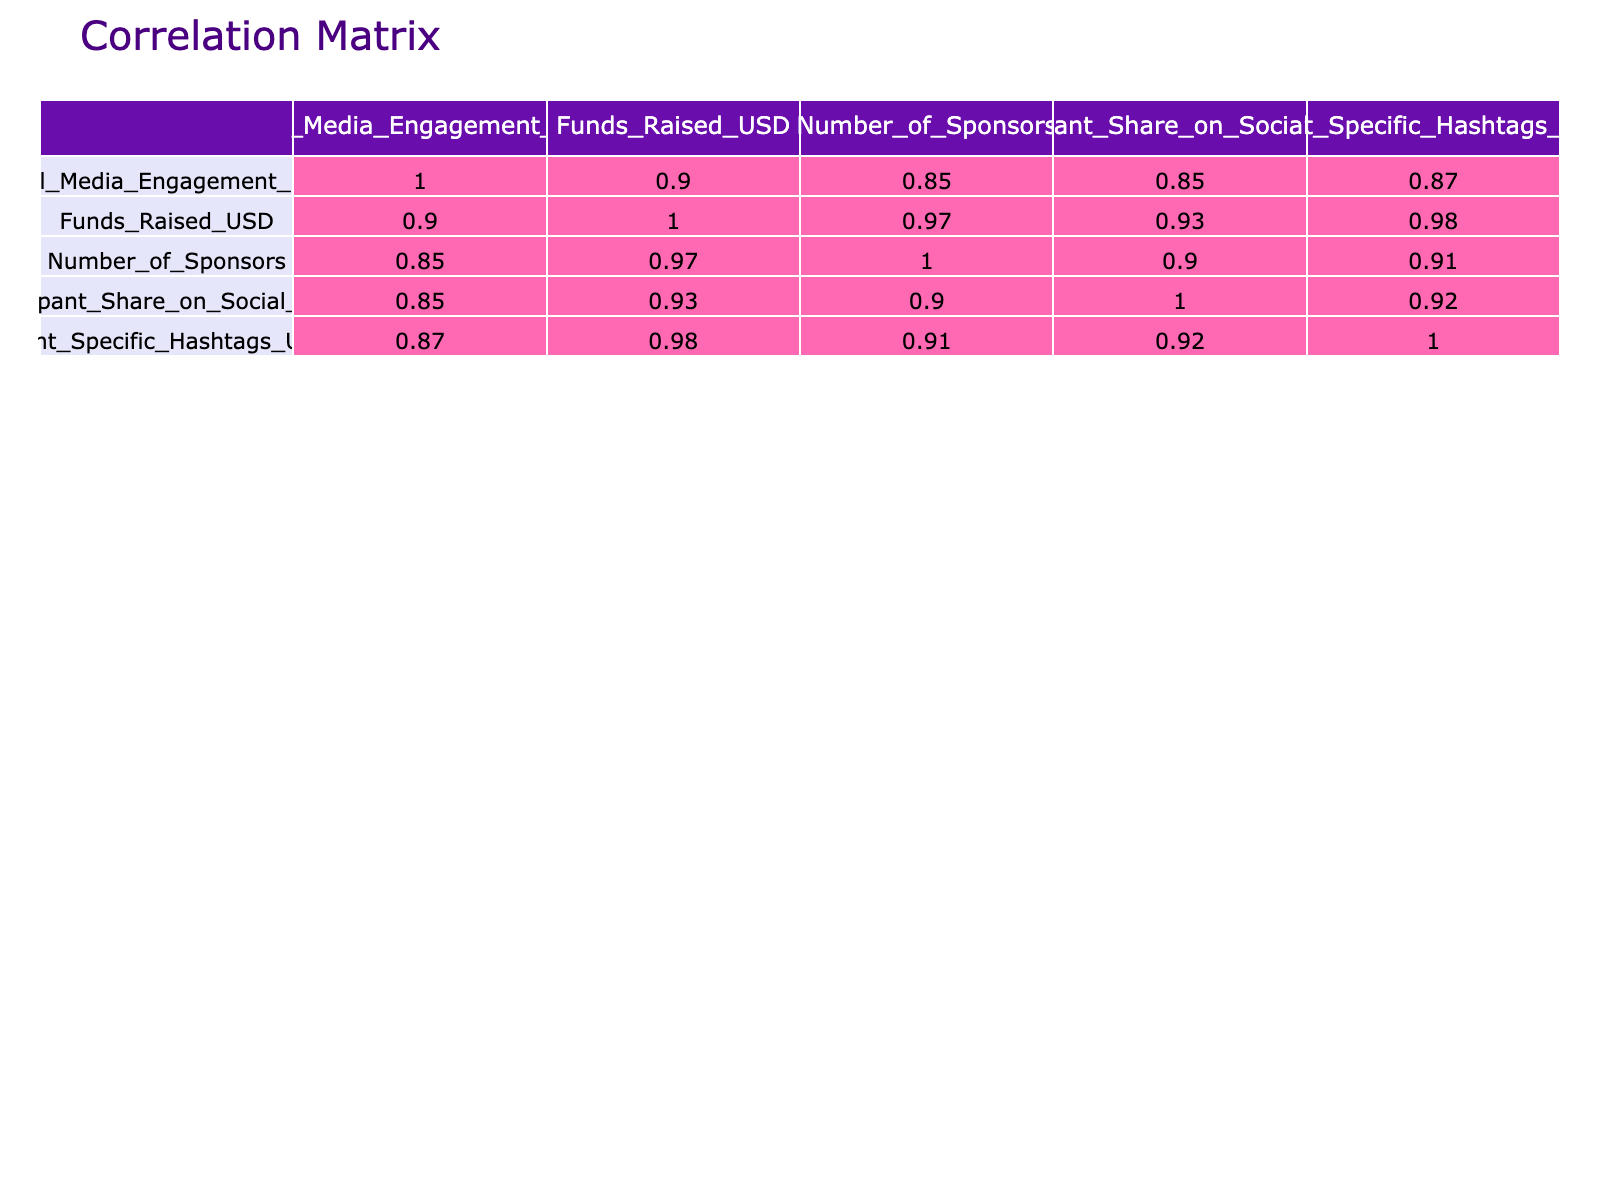What is the social media engagement score of the "Marathon for Mental Health" event? The social media engagement score for this event can be found directly in the table under the corresponding row labeled "Marathon for Mental Health." It shows a score of 90.
Answer: 90 What is the total funds raised by events that had a social media engagement score above 80? First, identify the events with a score above 80: "Run for Change," "Miles for Miracles," "Marathon for Mental Health," and "Global Run for Peace." Their corresponding funds raised are 50000, 75000, 90000, and 120000 respectively. Adding these gives: 50000 + 75000 + 90000 + 120000 = 345000.
Answer: 345000 Is there an event that raised more than 100000 USD? By evaluating the funds raised for each event in the table, none of the events have raised more than 100000 USD as the maximum amount listed is 120000 USD. Therefore, the answer is no.
Answer: No How many sponsors did the event "Global Run for Peace" have? From looking at the row for the event "Global Run for Peace," the number of sponsors is listed as 20.
Answer: 20 What is the average funds raised for events with fewer than 10 sponsors? First, identify the events with fewer than 10 sponsors: "Health Walkathon" (15000), "Fun Run for Friends" (45000), and "Kids Charity Run" (40000). Adding these gives: 15000 + 45000 + 40000 = 100000, and there are 3 events. The average is 100000 / 3 = 33333.33, which we can round to 33333.
Answer: 33333 Is there a positive correlation between social media engagement score and funds raised? By checking the correlation coefficient between these two variables in the table, we can observe that the values are positive, indicating that generally, as social media engagement increases, funds raised also tend to increase.
Answer: Yes What is the difference between the highest and lowest social media engagement score? The highest score is from "Global Run for Peace" with 100, and the lowest is "Eco Run" with 50. The difference is calculated by subtracting the lowest from the highest: 100 - 50 = 50.
Answer: 50 How much money was raised by the event with the lowest social media engagement score? Looking at the table identifies "Eco Run" has the lowest score at 50, and the funds raised for this event are 20000 USD.
Answer: 20000 How does the number of participants sharing on social media correlate with the funds raised? To answer this, we can review the correlation coefficient between "Participant Share on Social Media" and "Funds Raised." It would require checking values that show a trend of increased funds as participant shares increase, suggesting a positive correlation.
Answer: Positive correlation 